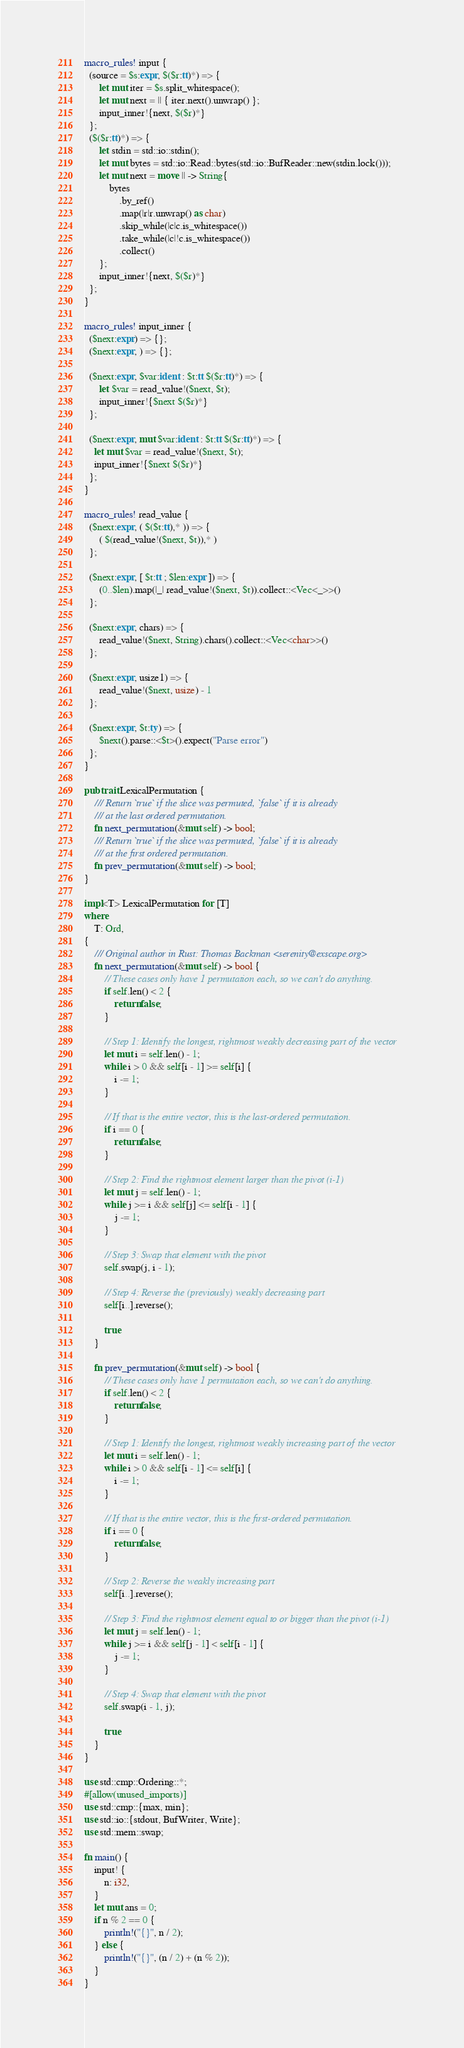<code> <loc_0><loc_0><loc_500><loc_500><_Rust_>macro_rules! input {
  (source = $s:expr, $($r:tt)*) => {
      let mut iter = $s.split_whitespace();
      let mut next = || { iter.next().unwrap() };
      input_inner!{next, $($r)*}
  };
  ($($r:tt)*) => {
      let stdin = std::io::stdin();
      let mut bytes = std::io::Read::bytes(std::io::BufReader::new(stdin.lock()));
      let mut next = move || -> String{
          bytes
              .by_ref()
              .map(|r|r.unwrap() as char)
              .skip_while(|c|c.is_whitespace())
              .take_while(|c|!c.is_whitespace())
              .collect()
      };
      input_inner!{next, $($r)*}
  };
}

macro_rules! input_inner {
  ($next:expr) => {};
  ($next:expr, ) => {};

  ($next:expr, $var:ident : $t:tt $($r:tt)*) => {
      let $var = read_value!($next, $t);
      input_inner!{$next $($r)*}
  };

  ($next:expr, mut $var:ident : $t:tt $($r:tt)*) => {
    let mut $var = read_value!($next, $t);
    input_inner!{$next $($r)*}
  };
}

macro_rules! read_value {
  ($next:expr, ( $($t:tt),* )) => {
      ( $(read_value!($next, $t)),* )
  };

  ($next:expr, [ $t:tt ; $len:expr ]) => {
      (0..$len).map(|_| read_value!($next, $t)).collect::<Vec<_>>()
  };

  ($next:expr, chars) => {
      read_value!($next, String).chars().collect::<Vec<char>>()
  };

  ($next:expr, usize1) => {
      read_value!($next, usize) - 1
  };

  ($next:expr, $t:ty) => {
      $next().parse::<$t>().expect("Parse error")
  };
}

pub trait LexicalPermutation {
    /// Return `true` if the slice was permuted, `false` if it is already
    /// at the last ordered permutation.
    fn next_permutation(&mut self) -> bool;
    /// Return `true` if the slice was permuted, `false` if it is already
    /// at the first ordered permutation.
    fn prev_permutation(&mut self) -> bool;
}

impl<T> LexicalPermutation for [T]
where
    T: Ord,
{
    /// Original author in Rust: Thomas Backman <serenity@exscape.org>
    fn next_permutation(&mut self) -> bool {
        // These cases only have 1 permutation each, so we can't do anything.
        if self.len() < 2 {
            return false;
        }

        // Step 1: Identify the longest, rightmost weakly decreasing part of the vector
        let mut i = self.len() - 1;
        while i > 0 && self[i - 1] >= self[i] {
            i -= 1;
        }

        // If that is the entire vector, this is the last-ordered permutation.
        if i == 0 {
            return false;
        }

        // Step 2: Find the rightmost element larger than the pivot (i-1)
        let mut j = self.len() - 1;
        while j >= i && self[j] <= self[i - 1] {
            j -= 1;
        }

        // Step 3: Swap that element with the pivot
        self.swap(j, i - 1);

        // Step 4: Reverse the (previously) weakly decreasing part
        self[i..].reverse();

        true
    }

    fn prev_permutation(&mut self) -> bool {
        // These cases only have 1 permutation each, so we can't do anything.
        if self.len() < 2 {
            return false;
        }

        // Step 1: Identify the longest, rightmost weakly increasing part of the vector
        let mut i = self.len() - 1;
        while i > 0 && self[i - 1] <= self[i] {
            i -= 1;
        }

        // If that is the entire vector, this is the first-ordered permutation.
        if i == 0 {
            return false;
        }

        // Step 2: Reverse the weakly increasing part
        self[i..].reverse();

        // Step 3: Find the rightmost element equal to or bigger than the pivot (i-1)
        let mut j = self.len() - 1;
        while j >= i && self[j - 1] < self[i - 1] {
            j -= 1;
        }

        // Step 4: Swap that element with the pivot
        self.swap(i - 1, j);

        true
    }
}

use std::cmp::Ordering::*;
#[allow(unused_imports)]
use std::cmp::{max, min};
use std::io::{stdout, BufWriter, Write};
use std::mem::swap;

fn main() {
    input! {
        n: i32,
    }
    let mut ans = 0;
    if n % 2 == 0 {
        println!("{}", n / 2);
    } else {
        println!("{}", (n / 2) + (n % 2));
    }
}</code> 